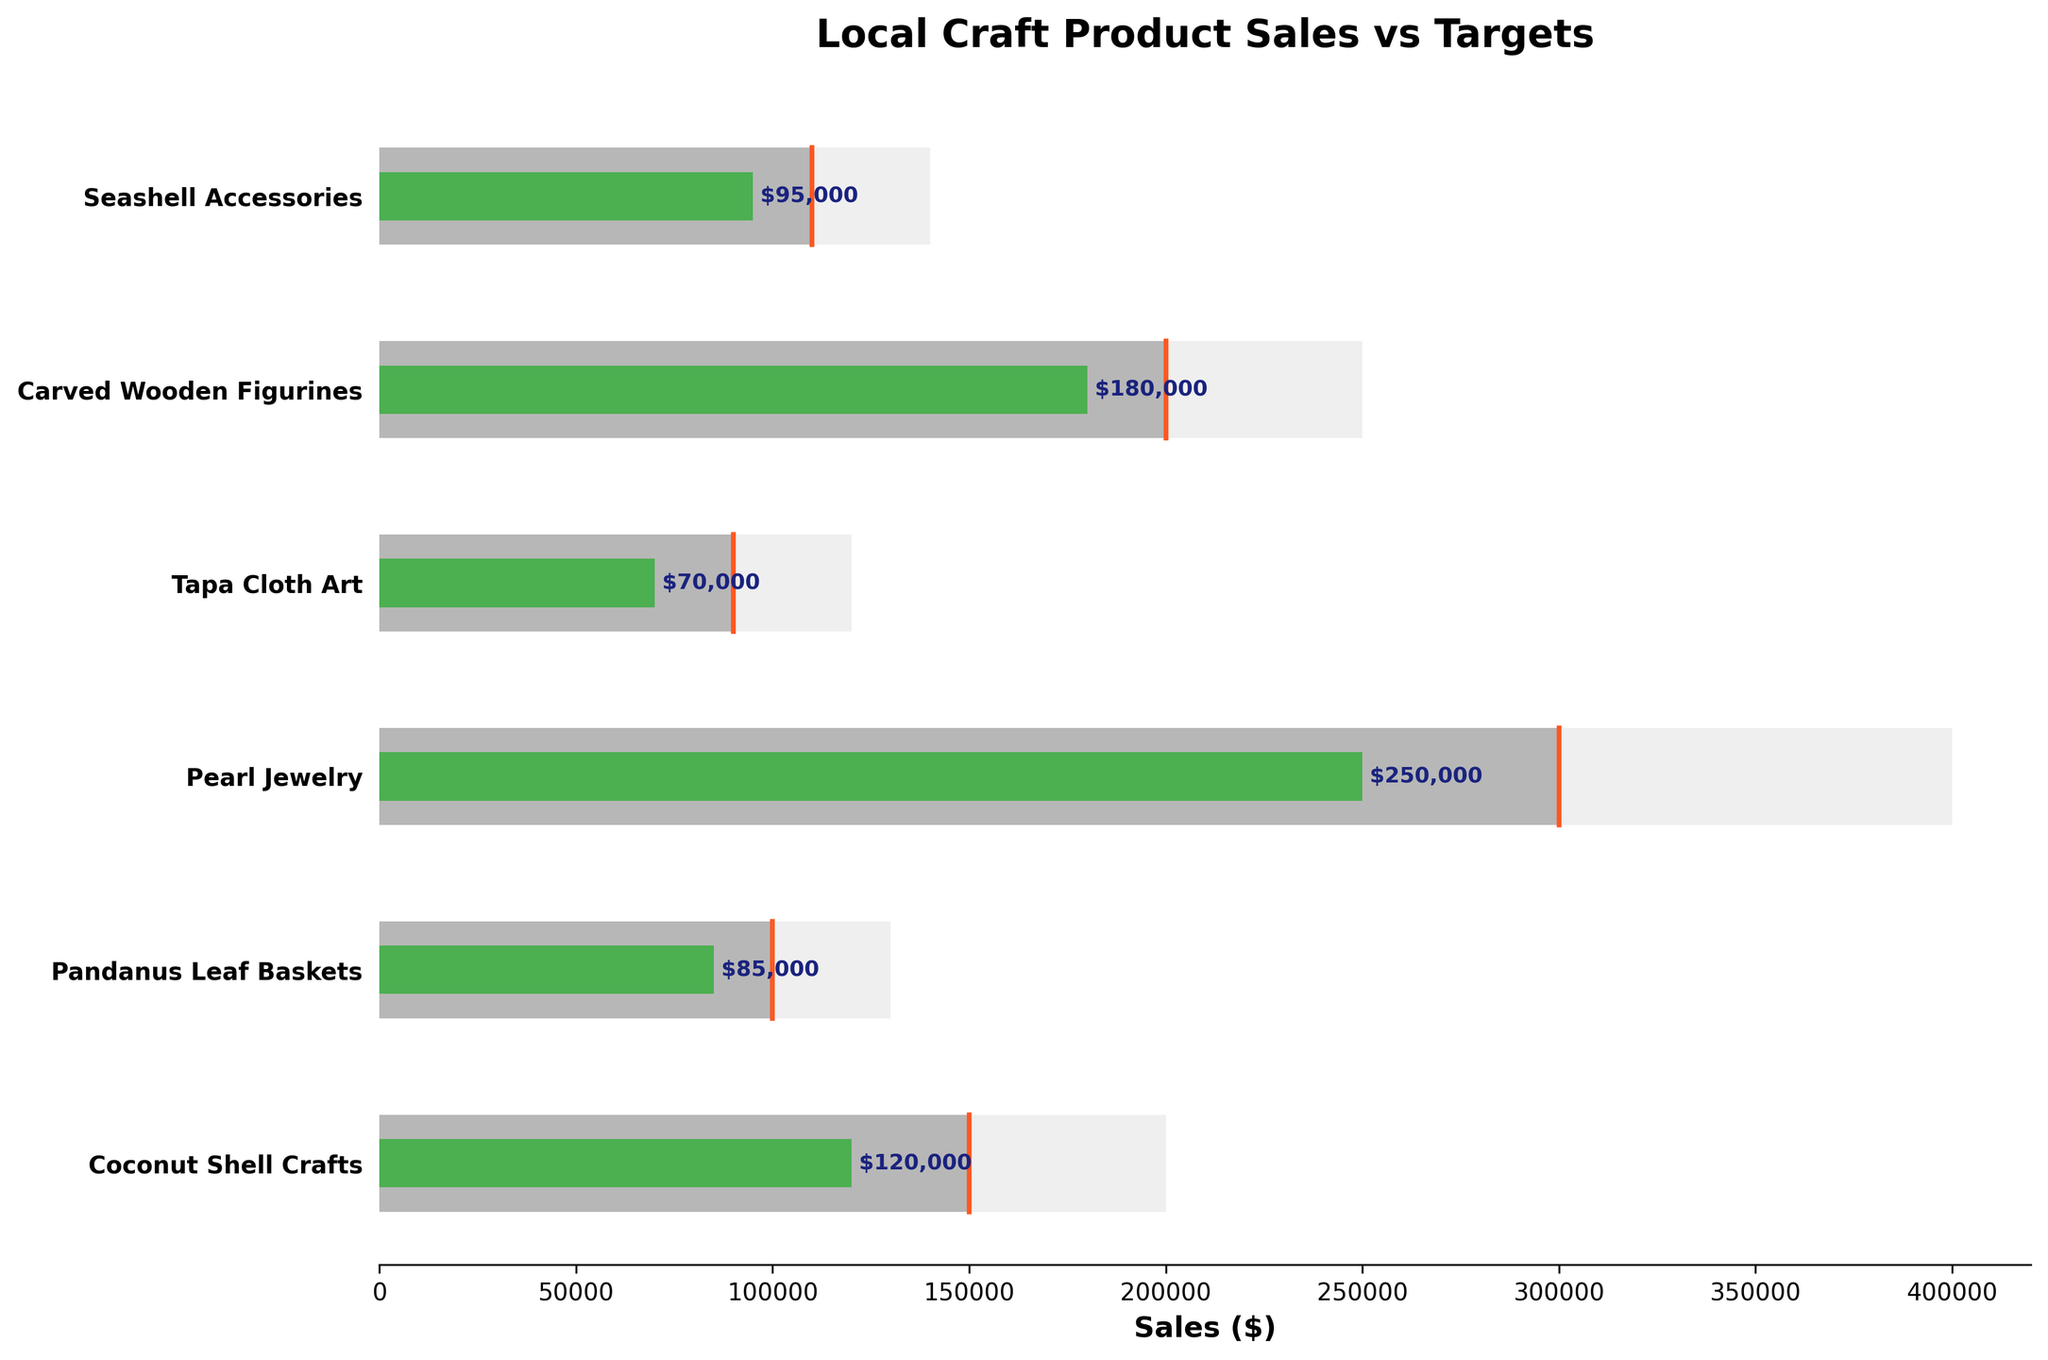What's the title of the chart? The big text at the top of the chart specifies the title.
Answer: Local Craft Product Sales vs Targets What are the three categories of sales data shown for each product? Observing the different colored bars, we see that the chart has three categories: maximum potential sales, target sales, and actual sales.
Answer: Maximum Potential, Target, and Actual Sales Which product has the highest actual sales? To determine this, look at the green bars representing actual sales and compare their lengths. The longest green bar represents the highest actual sales.
Answer: Pearl Jewelry What is the actual sales figure for Pandanus Leaf Baskets? Check the green bar representing actual sales for Pandanus Leaf Baskets and read the label beside it.
Answer: $85,000 Compare the target sales and actual sales for Carved Wooden Figurines. Look at the grey bar (target sales) and the green bar (actual sales) for Carved Wooden Figurines and compare their lengths and values. The target sales are $200,000, while the actual sales are $180,000.
Answer: Target: $200,000, Actual: $180,000 How far is Seashell Accessories from reaching its target sales? Find the difference between the Seashell Accessories' target sales and actual sales. Target is $110,000 and actual is $95,000: $110,000 - $95,000 = $15,000.
Answer: $15,000 Which product has the smallest gap between target sales and actual sales? Calculate the difference between target sales and actual sales for each product, and find the smallest difference. The differences are: Coconut Shell Crafts: $150,000 - $120,000 = $30,000; Pandanus Leaf Baskets: $100,000 - $85,000 = $15,000; Pearl Jewelry: $300,000 - $250,000 = $50,000; Tapa Cloth Art: $90,000 - $70,000 = $20,000; Carved Wooden Figurines: $200,000 - $180,000 = $20,000; Seashell Accessories: $110,000 - $95,000 = $15,000. The smallest gap is for Pandanus Leaf Baskets and Seashell Accessories, both $15,000.
Answer: Pandanus Leaf Baskets and Seashell Accessories (both $15,000) How many products have actual sales that exceed half of their maximum potential sales? For each product, check if the actual sales are greater than half of the maximum potential. The products meeting this criterion are: Coconut Shell Crafts: $120,000 > $100,000, Pearl Jewelry: $250,000 > $200,000, Carved Wooden Figurines: $180,000 > $125,000, Seashell Accessories: $95,000 > $70,000.
Answer: 4 products What is the difference between the maximum potential and actual sales for Tapa Cloth Art? Subtract the actual sales of Tapa Cloth Art from its maximum potential sales. $120,000 - $70,000 = $50,000.
Answer: $50,000 